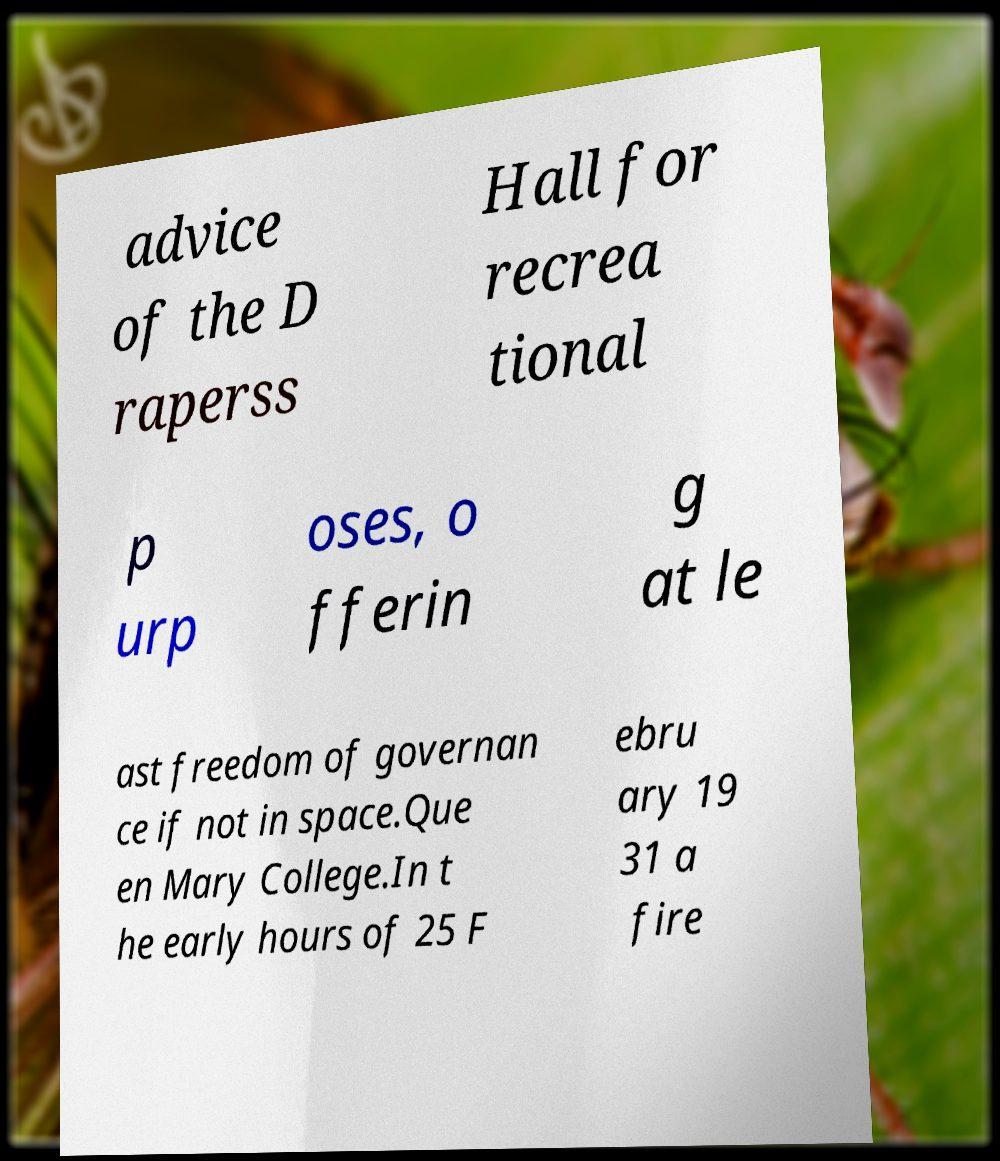Can you read and provide the text displayed in the image?This photo seems to have some interesting text. Can you extract and type it out for me? advice of the D raperss Hall for recrea tional p urp oses, o fferin g at le ast freedom of governan ce if not in space.Que en Mary College.In t he early hours of 25 F ebru ary 19 31 a fire 